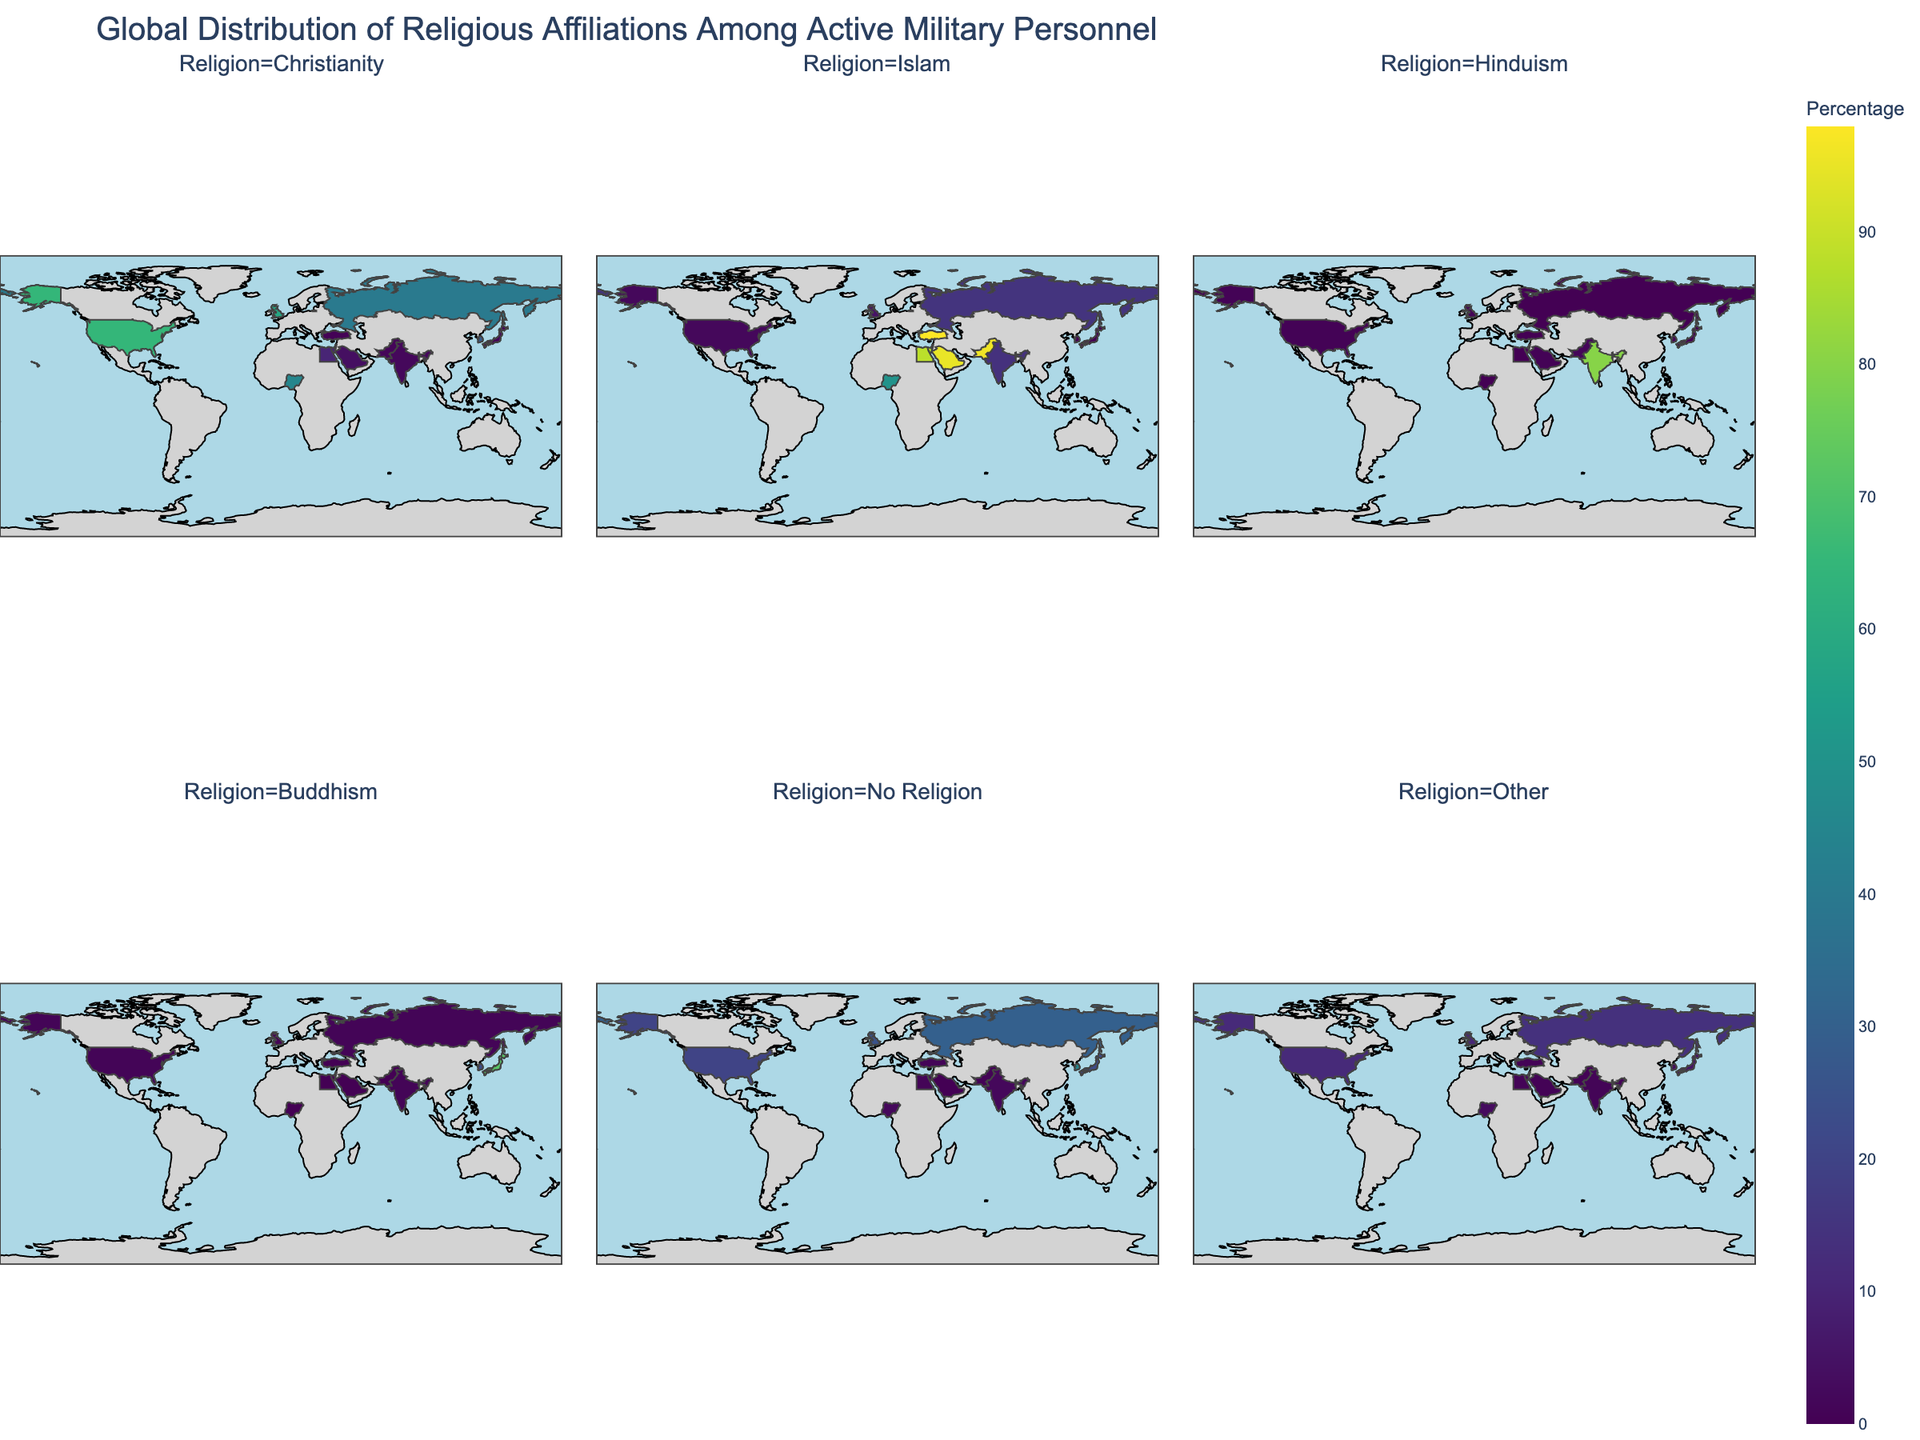Which country has the highest percentage of personnel with no religion? To answer this, locate the facet plot corresponding to 'No Religion'. Then, look at the percentages displayed for each country. Identify the country with the highest percentage.
Answer: South Korea Which religion has the smallest percentage of personnel in Russia? Look at the facet plot for Russia and compare the percentages for each religion. Identify the smallest value.
Answer: Hinduism What is the total percentage of military personnel identifying as Christian in the United States and the United Kingdom combined? First, find the percentage of Christian military personnel in each country using the 'Christianity' facet. Add these two values together: United States (65) + United Kingdom (58).
Answer: 123 How does the percentage of Muslim personnel in Turkey compare to that in Pakistan? Find the percentage of Muslim personnel in Turkey and Pakistan using the 'Islam' facet. Compare these values.
Answer: Turkey has 98% while Pakistan has 96% Which country has the highest percentage of Hindu military personnel? Navigate to the 'Hinduism' facet and identify the country with the highest percentage.
Answer: India How many countries have more than 50% military personnel identifying as Christian? Look at the 'Christianity' facet and count the number of countries where the percentage exceeds 50%.
Answer: 3 Is there any country where Buddhism is the predominant religion among military personnel? Check each country's percentage in the 'Buddhism' facet to see if any country has Buddhism as the highest percentage compared to other religions in that country.
Answer: Japan What is the average percentage of personnel with 'Other' religions in Israel and South Korea? Identify the 'Other' percentages for Israel and South Korea, then calculate the average: (57.5 + 2.8) / 2.
Answer: 30.15 Which country has the most diverse range of religious affiliations among its military personnel? To determine this, look for the country whose facets display the most varied percentages across different religions.
Answer: United States 